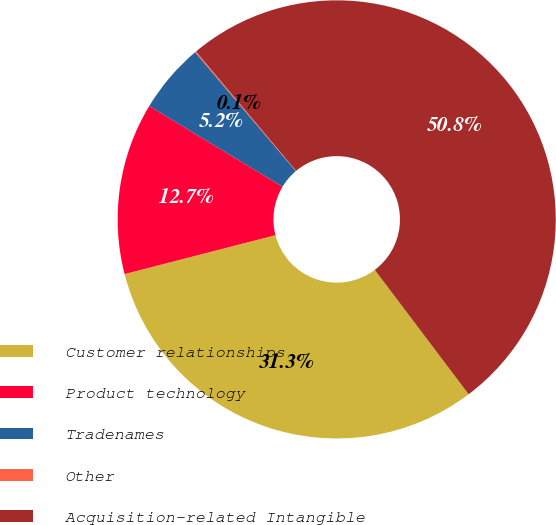<chart> <loc_0><loc_0><loc_500><loc_500><pie_chart><fcel>Customer relationships<fcel>Product technology<fcel>Tradenames<fcel>Other<fcel>Acquisition-related Intangible<nl><fcel>31.27%<fcel>12.67%<fcel>5.16%<fcel>0.09%<fcel>50.81%<nl></chart> 